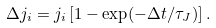<formula> <loc_0><loc_0><loc_500><loc_500>\Delta j _ { i } = j _ { i } \left [ 1 - \exp ( - \Delta t / \tau _ { J } ) \right ] .</formula> 